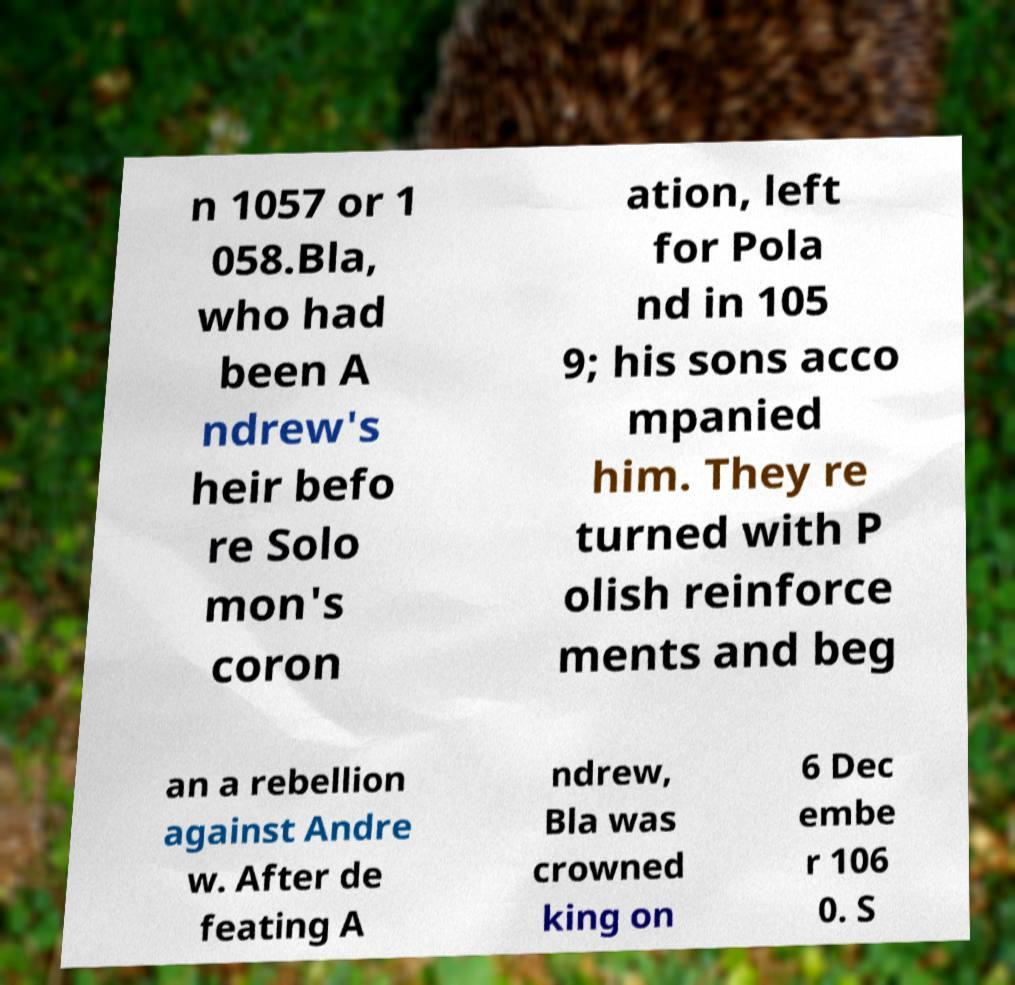What messages or text are displayed in this image? I need them in a readable, typed format. n 1057 or 1 058.Bla, who had been A ndrew's heir befo re Solo mon's coron ation, left for Pola nd in 105 9; his sons acco mpanied him. They re turned with P olish reinforce ments and beg an a rebellion against Andre w. After de feating A ndrew, Bla was crowned king on 6 Dec embe r 106 0. S 